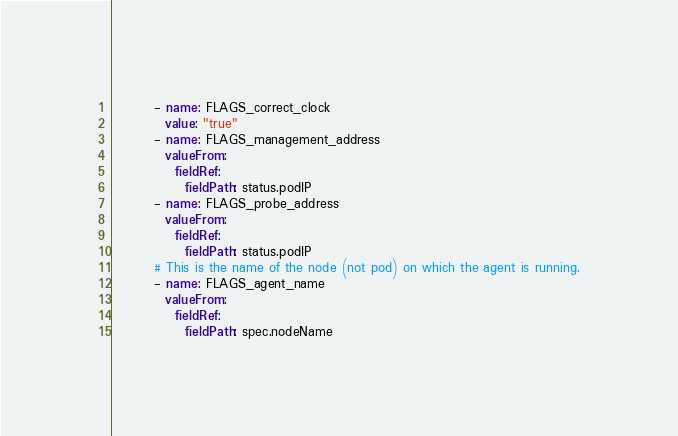Convert code to text. <code><loc_0><loc_0><loc_500><loc_500><_YAML_>        - name: FLAGS_correct_clock
          value: "true"
        - name: FLAGS_management_address
          valueFrom:
            fieldRef:
              fieldPath: status.podIP
        - name: FLAGS_probe_address
          valueFrom:
            fieldRef:
              fieldPath: status.podIP
        # This is the name of the node (not pod) on which the agent is running.
        - name: FLAGS_agent_name
          valueFrom:
            fieldRef:
              fieldPath: spec.nodeName
</code> 